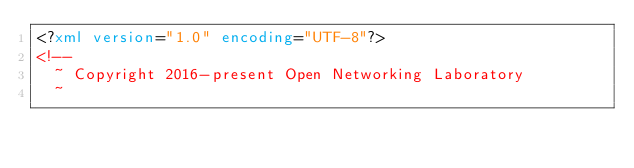Convert code to text. <code><loc_0><loc_0><loc_500><loc_500><_XML_><?xml version="1.0" encoding="UTF-8"?>
<!--
  ~ Copyright 2016-present Open Networking Laboratory
  ~</code> 